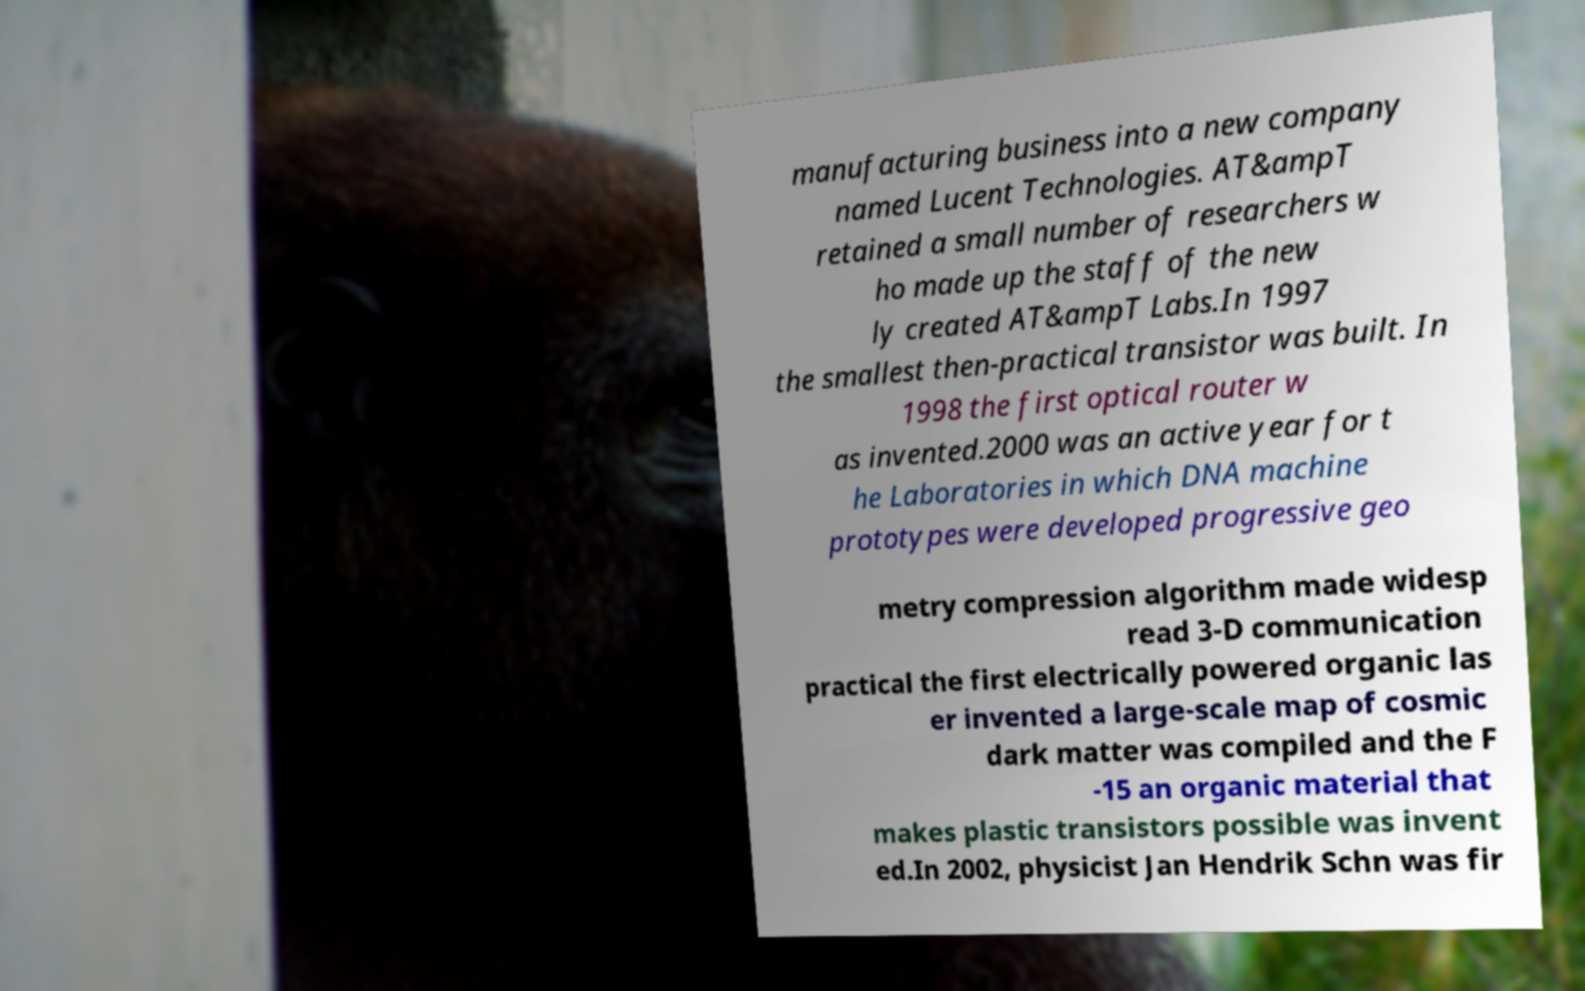Could you extract and type out the text from this image? manufacturing business into a new company named Lucent Technologies. AT&ampT retained a small number of researchers w ho made up the staff of the new ly created AT&ampT Labs.In 1997 the smallest then-practical transistor was built. In 1998 the first optical router w as invented.2000 was an active year for t he Laboratories in which DNA machine prototypes were developed progressive geo metry compression algorithm made widesp read 3-D communication practical the first electrically powered organic las er invented a large-scale map of cosmic dark matter was compiled and the F -15 an organic material that makes plastic transistors possible was invent ed.In 2002, physicist Jan Hendrik Schn was fir 